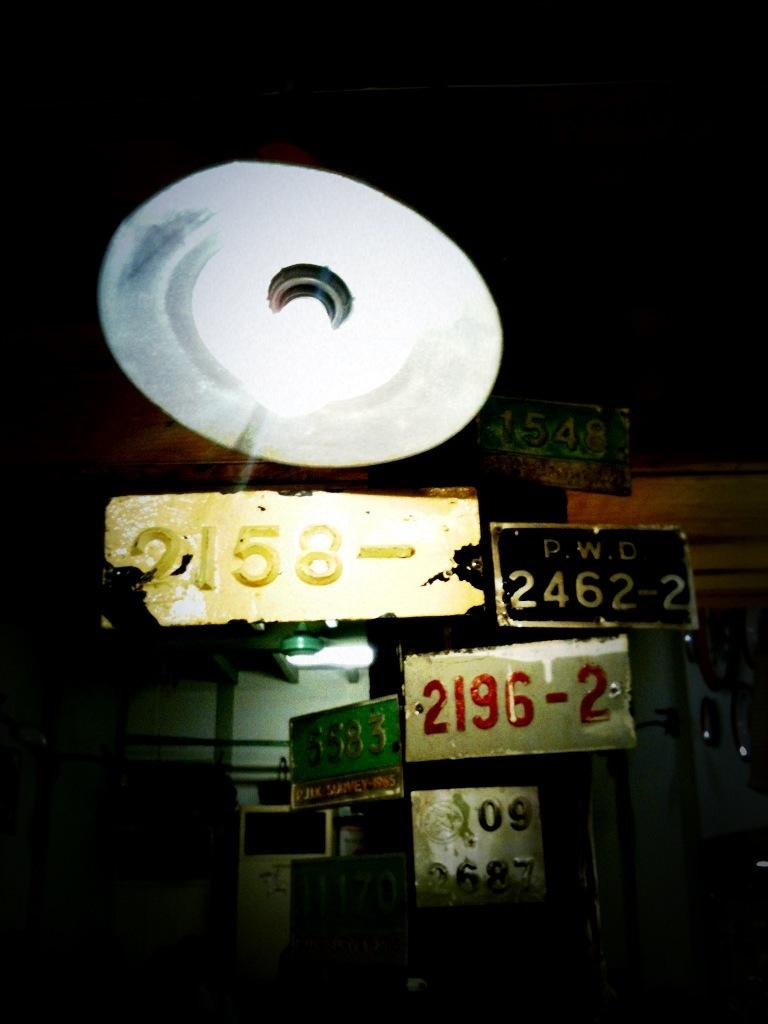<image>
Render a clear and concise summary of the photo. Many license plates hanging with one that says 2462-2 on it. 